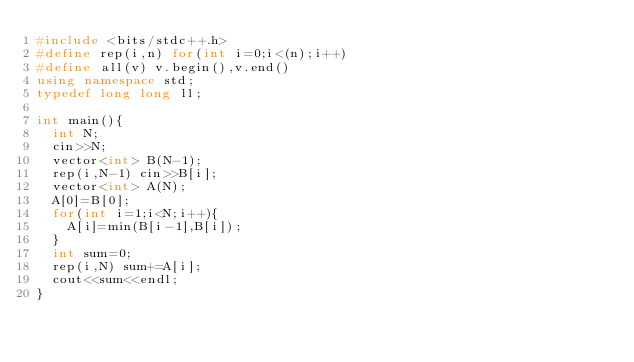Convert code to text. <code><loc_0><loc_0><loc_500><loc_500><_C++_>#include <bits/stdc++.h>
#define rep(i,n) for(int i=0;i<(n);i++)
#define all(v) v.begin(),v.end()
using namespace std;
typedef long long ll;
 
int main(){
  int N;
  cin>>N;
  vector<int> B(N-1);
  rep(i,N-1) cin>>B[i];
  vector<int> A(N);
  A[0]=B[0];
  for(int i=1;i<N;i++){
    A[i]=min(B[i-1],B[i]);
  }
  int sum=0;
  rep(i,N) sum+=A[i];
  cout<<sum<<endl;
}</code> 